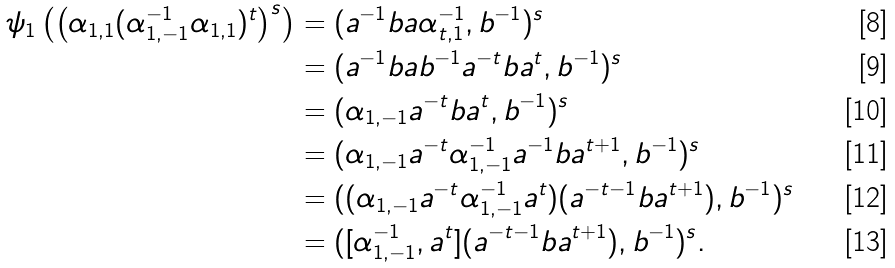<formula> <loc_0><loc_0><loc_500><loc_500>\psi _ { 1 } \left ( \left ( \alpha _ { 1 , 1 } ( \alpha _ { 1 , - 1 } ^ { - 1 } \alpha _ { 1 , 1 } ) ^ { t } \right ) ^ { s } \right ) & = ( a ^ { - 1 } b a \alpha _ { t , 1 } ^ { - 1 } , b ^ { - 1 } ) ^ { s } \\ & = ( a ^ { - 1 } b a b ^ { - 1 } a ^ { - t } b a ^ { t } , b ^ { - 1 } ) ^ { s } \\ & = ( \alpha _ { 1 , - 1 } a ^ { - t } b a ^ { t } , b ^ { - 1 } ) ^ { s } \\ & = ( \alpha _ { 1 , - 1 } a ^ { - t } \alpha _ { 1 , - 1 } ^ { - 1 } a ^ { - 1 } b a ^ { t + 1 } , b ^ { - 1 } ) ^ { s } \\ & = ( ( \alpha _ { 1 , - 1 } a ^ { - t } \alpha _ { 1 , - 1 } ^ { - 1 } a ^ { t } ) ( a ^ { - t - 1 } b a ^ { t + 1 } ) , b ^ { - 1 } ) ^ { s } \\ & = ( [ \alpha _ { 1 , - 1 } ^ { - 1 } , a ^ { t } ] ( a ^ { - t - 1 } b a ^ { t + 1 } ) , b ^ { - 1 } ) ^ { s } .</formula> 